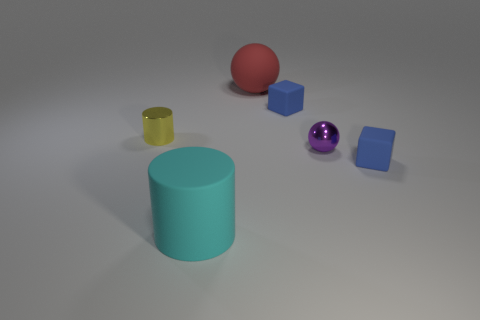What is the shape of the cyan object that is the same size as the red ball? cylinder 